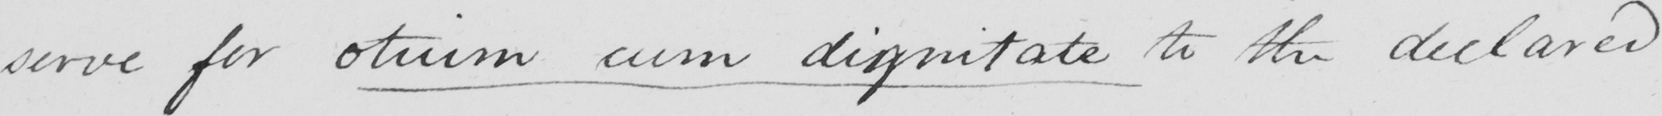Can you tell me what this handwritten text says? serve for otuim cum dignitate to the declared 